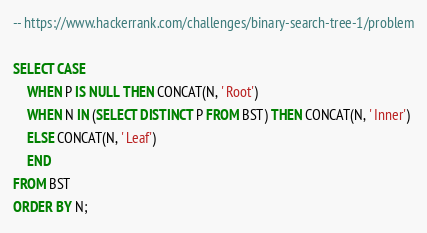Convert code to text. <code><loc_0><loc_0><loc_500><loc_500><_SQL_>-- https://www.hackerrank.com/challenges/binary-search-tree-1/problem

SELECT CASE 
    WHEN P IS NULL THEN CONCAT(N, ' Root')
    WHEN N IN (SELECT DISTINCT P FROM BST) THEN CONCAT(N, ' Inner')
    ELSE CONCAT(N, ' Leaf')
    END
FROM BST
ORDER BY N;</code> 